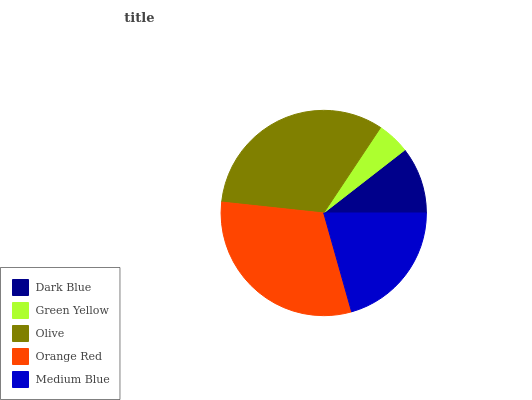Is Green Yellow the minimum?
Answer yes or no. Yes. Is Olive the maximum?
Answer yes or no. Yes. Is Olive the minimum?
Answer yes or no. No. Is Green Yellow the maximum?
Answer yes or no. No. Is Olive greater than Green Yellow?
Answer yes or no. Yes. Is Green Yellow less than Olive?
Answer yes or no. Yes. Is Green Yellow greater than Olive?
Answer yes or no. No. Is Olive less than Green Yellow?
Answer yes or no. No. Is Medium Blue the high median?
Answer yes or no. Yes. Is Medium Blue the low median?
Answer yes or no. Yes. Is Green Yellow the high median?
Answer yes or no. No. Is Orange Red the low median?
Answer yes or no. No. 